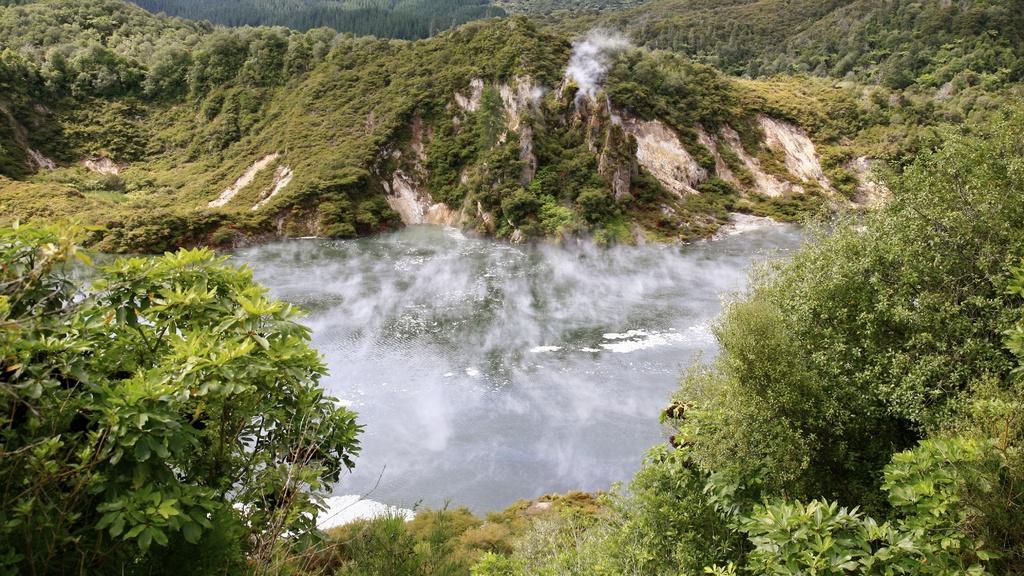Please provide a concise description of this image. In this image there are some trees mountains and in the center there is some fog, and in the background also there are some trees and mountains. 